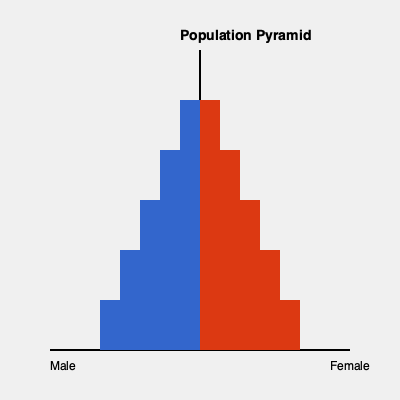Based on the population pyramid shown, which demographic trend could potentially influence your campaign strategy for the upcoming election? To answer this question, let's analyze the population pyramid step-by-step:

1. Shape analysis: The pyramid has a relatively wide base that narrows towards the top. This indicates a growing population with a higher proportion of younger individuals.

2. Gender distribution: The pyramid is roughly symmetrical, suggesting a fairly even distribution between males and females across age groups.

3. Age structure:
   a. The widest bars at the bottom represent the youngest age group (0-14 years).
   b. The middle sections represent working-age adults (15-64 years).
   c. The narrowest bars at the top represent the elderly population (65+ years).

4. Political implications:
   a. Large youth population: This suggests a need to focus on issues that appeal to younger voters, such as education, job creation, and technology.
   b. Significant working-age population: Policies related to employment, taxes, and economic growth could be crucial.
   c. Smaller elderly population: While smaller, this group typically has high voter turnout, so healthcare and retirement issues shouldn't be ignored.

5. Future trends: The wide base suggests continued population growth, which could lead to increased demand for public services and infrastructure in the coming years.

6. Voter engagement: Different age groups may require different outreach strategies. For example, younger voters might be more responsive to social media campaigns, while older voters might prefer traditional media.

Given this analysis, the most significant demographic trend that could influence campaign strategy is the large youth population, as they represent both current and future voters, and their concerns may shape the political landscape in the coming years.
Answer: Large youth population 